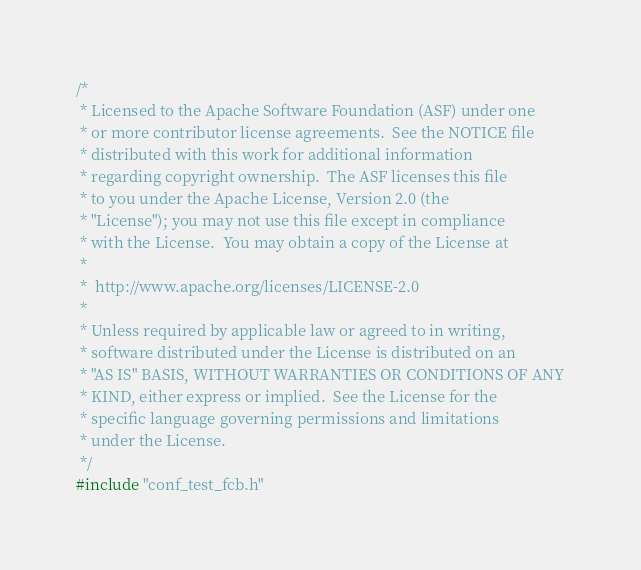Convert code to text. <code><loc_0><loc_0><loc_500><loc_500><_C_>/*
 * Licensed to the Apache Software Foundation (ASF) under one
 * or more contributor license agreements.  See the NOTICE file
 * distributed with this work for additional information
 * regarding copyright ownership.  The ASF licenses this file
 * to you under the Apache License, Version 2.0 (the
 * "License"); you may not use this file except in compliance
 * with the License.  You may obtain a copy of the License at
 *
 *  http://www.apache.org/licenses/LICENSE-2.0
 *
 * Unless required by applicable law or agreed to in writing,
 * software distributed under the License is distributed on an
 * "AS IS" BASIS, WITHOUT WARRANTIES OR CONDITIONS OF ANY
 * KIND, either express or implied.  See the License for the
 * specific language governing permissions and limitations
 * under the License.
 */
#include "conf_test_fcb.h"
</code> 